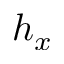<formula> <loc_0><loc_0><loc_500><loc_500>h _ { x }</formula> 